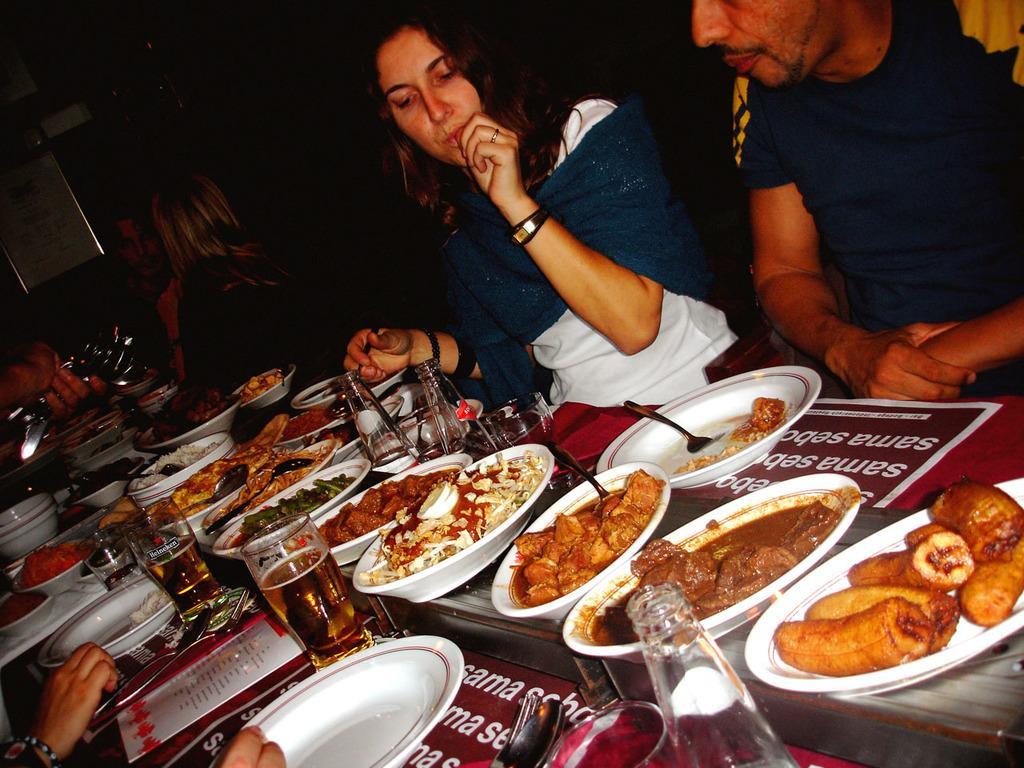Can you describe this image briefly? In this image, there are four people sitting. In front of these people, I can see a table with plates, bowls, food items, glasses, spoons, forks and few other objects. On the left side of the image, I can see a person's hand holding the spoons and there is a board. 